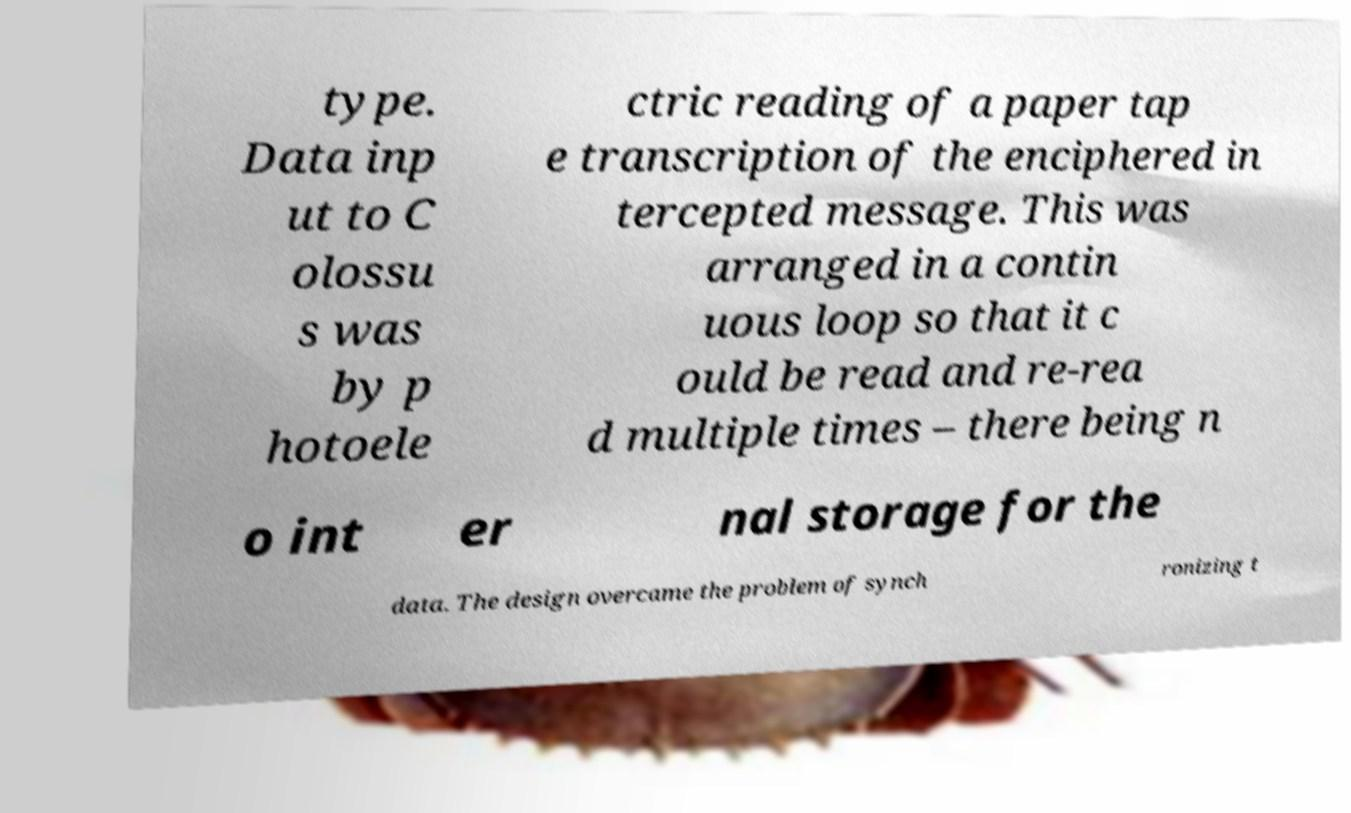There's text embedded in this image that I need extracted. Can you transcribe it verbatim? type. Data inp ut to C olossu s was by p hotoele ctric reading of a paper tap e transcription of the enciphered in tercepted message. This was arranged in a contin uous loop so that it c ould be read and re-rea d multiple times – there being n o int er nal storage for the data. The design overcame the problem of synch ronizing t 